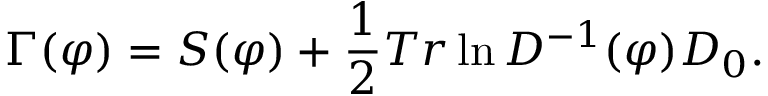<formula> <loc_0><loc_0><loc_500><loc_500>\Gamma ( \varphi ) = S ( \varphi ) + \frac { 1 } { 2 } T r \ln D ^ { - 1 } ( \varphi ) D _ { 0 } .</formula> 